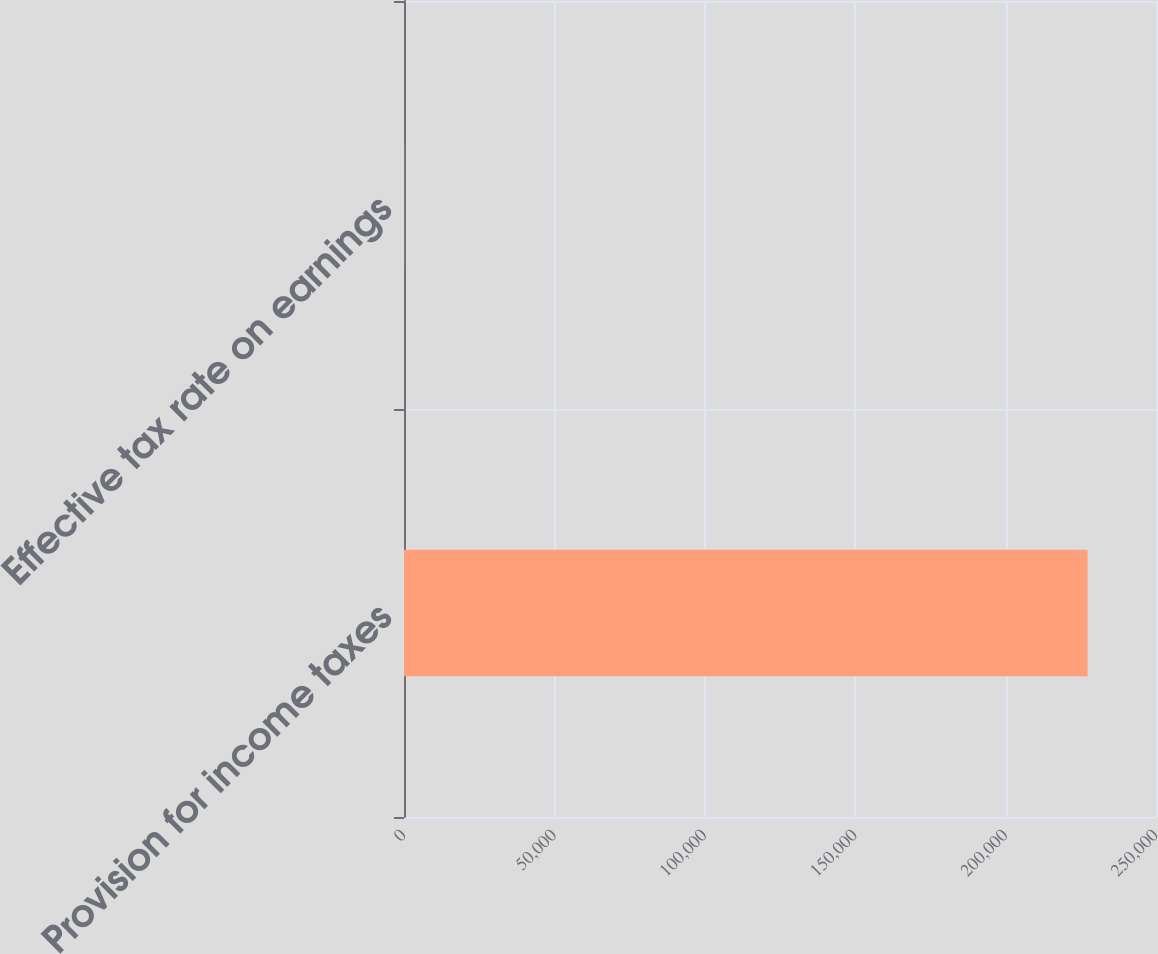<chart> <loc_0><loc_0><loc_500><loc_500><bar_chart><fcel>Provision for income taxes<fcel>Effective tax rate on earnings<nl><fcel>227242<fcel>36<nl></chart> 